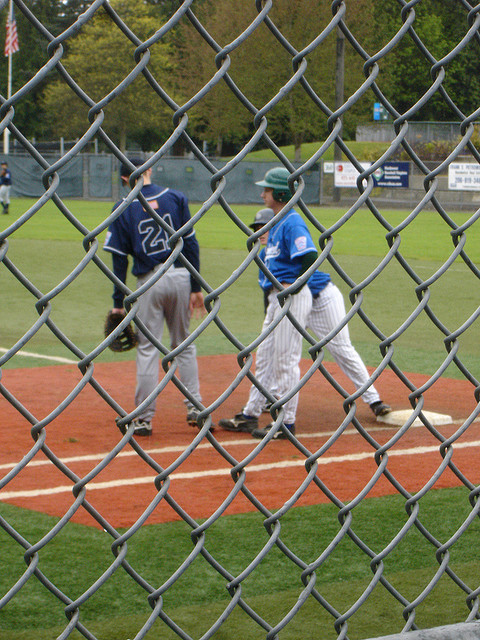Please extract the text content from this image. 21 